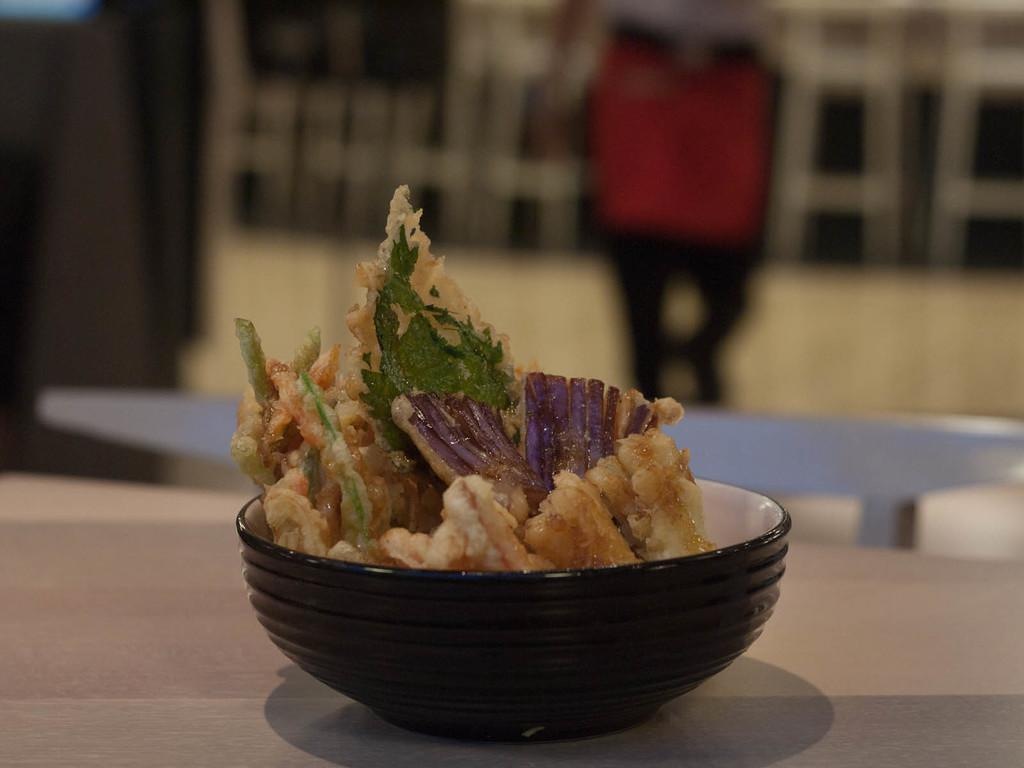What is present in the image that can hold items? There is a bowl in the image that can hold items. Where is the bowl located in the image? The bowl is on a surface in the image. What is inside the bowl? There is a food item in the bowl. Can you describe the background of the image? The background of the image is blurred. What type of society is depicted in the image? There is no society depicted in the image; it features a bowl with a food item on a surface. What date is shown on the calendar in the image? There is no calendar present in the image. 